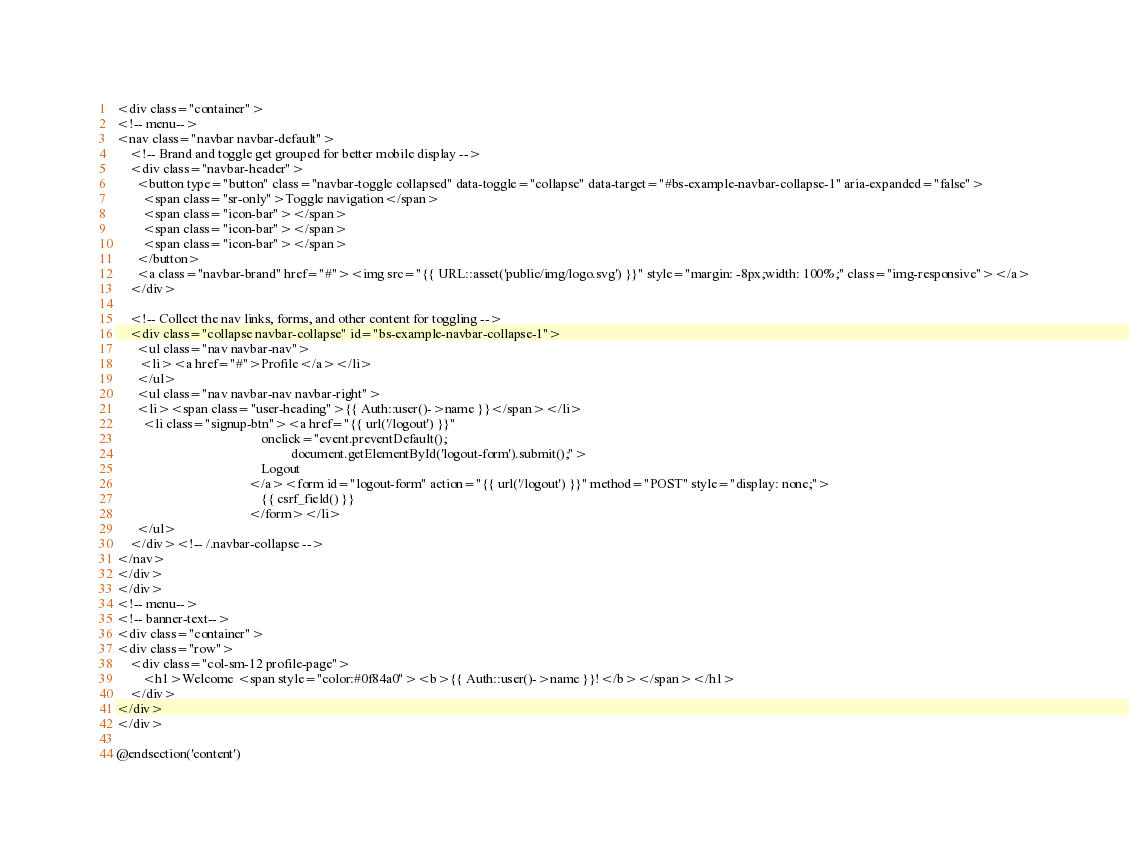Convert code to text. <code><loc_0><loc_0><loc_500><loc_500><_PHP_><div class="container">
<!-- menu-->
<nav class="navbar navbar-default">
    <!-- Brand and toggle get grouped for better mobile display -->
    <div class="navbar-header">
      <button type="button" class="navbar-toggle collapsed" data-toggle="collapse" data-target="#bs-example-navbar-collapse-1" aria-expanded="false">
        <span class="sr-only">Toggle navigation</span>
        <span class="icon-bar"></span>
        <span class="icon-bar"></span>
        <span class="icon-bar"></span>
      </button>
      <a class="navbar-brand" href="#"><img src="{{ URL::asset('public/img/logo.svg') }}" style="margin: -8px;width: 100%;" class="img-responsive"></a>
    </div>

    <!-- Collect the nav links, forms, and other content for toggling -->
    <div class="collapse navbar-collapse" id="bs-example-navbar-collapse-1">
      <ul class="nav navbar-nav">
       <li><a href="#">Profile</a></li>
      </ul>
      <ul class="nav navbar-nav navbar-right">
      <li><span class="user-heading">{{ Auth::user()->name }}</span></li>
        <li class="signup-btn"><a href="{{ url('/logout') }}"
                                            onclick="event.preventDefault();
                                                     document.getElementById('logout-form').submit();">
                                            Logout
                                        </a><form id="logout-form" action="{{ url('/logout') }}" method="POST" style="display: none;">
                                            {{ csrf_field() }}
                                        </form></li>
      </ul>
    </div><!-- /.navbar-collapse -->
</nav>
</div>
</div>
<!-- menu-->
<!-- banner-text-->
<div class="container">
<div class="row">
    <div class="col-sm-12 profile-page">
        <h1>Welcome <span style="color:#0f84a0"><b>{{ Auth::user()->name }}!</b></span></h1>
    </div>
</div>
</div>

@endsection('content')</code> 